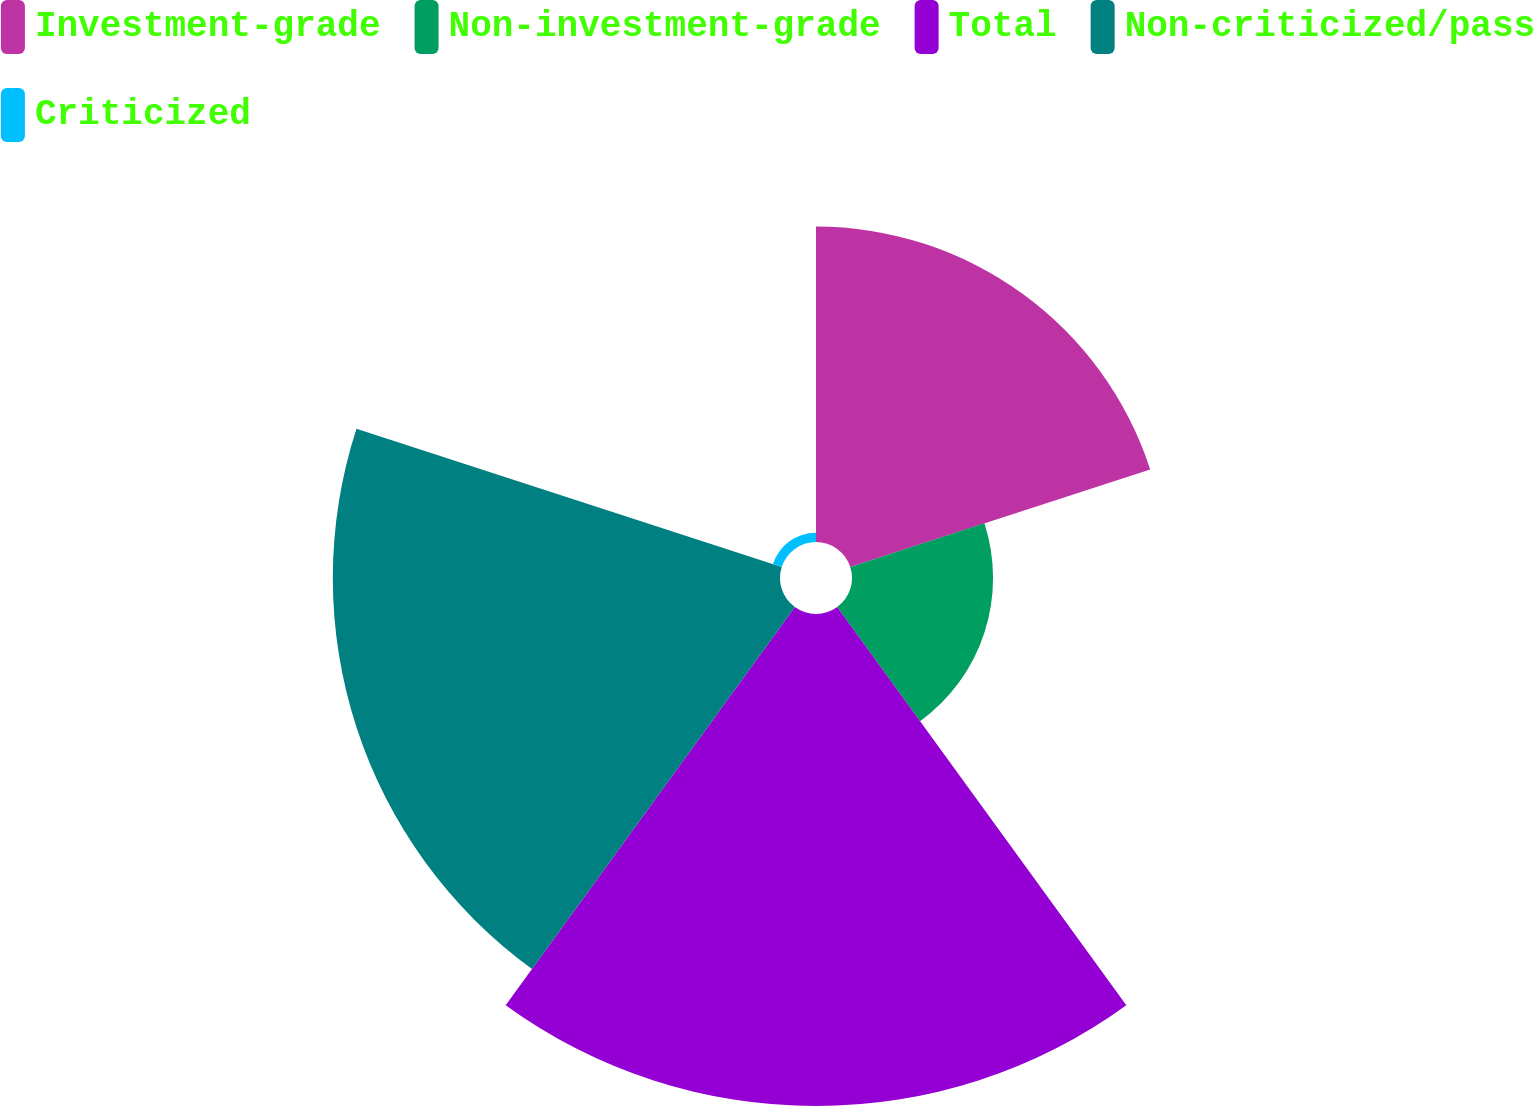<chart> <loc_0><loc_0><loc_500><loc_500><pie_chart><fcel>Investment-grade<fcel>Non-investment-grade<fcel>Total<fcel>Non-criticized/pass<fcel>Criticized<nl><fcel>22.45%<fcel>10.04%<fcel>35.02%<fcel>31.83%<fcel>0.66%<nl></chart> 